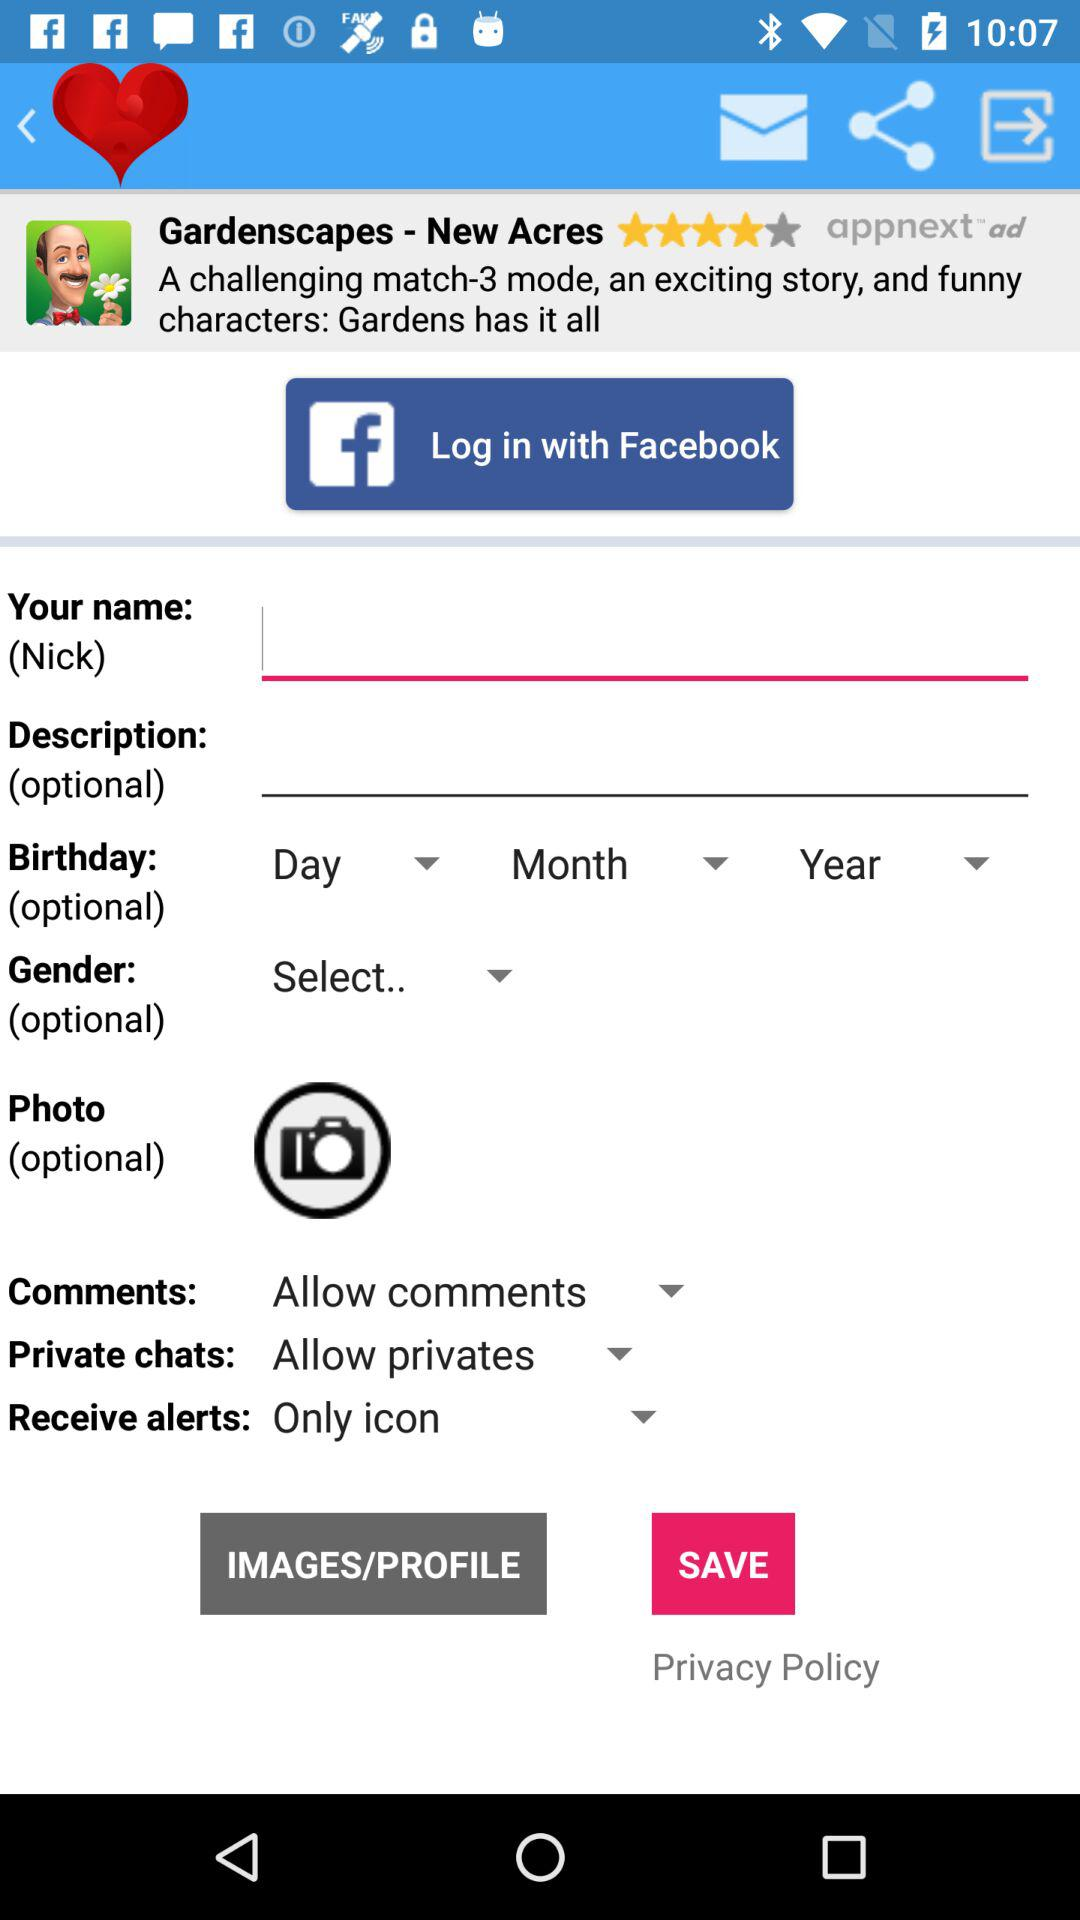Which account can I use to log in? You can use "Facebook" to log in. 